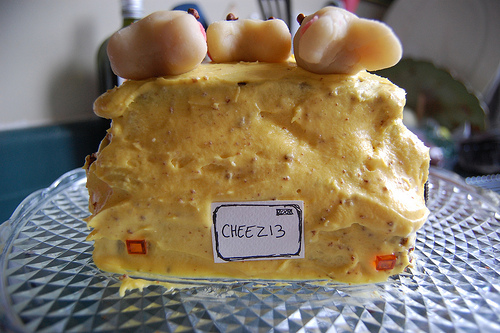<image>
Is the plate on the cake? No. The plate is not positioned on the cake. They may be near each other, but the plate is not supported by or resting on top of the cake. Is there a cheese above the bowl? No. The cheese is not positioned above the bowl. The vertical arrangement shows a different relationship. 